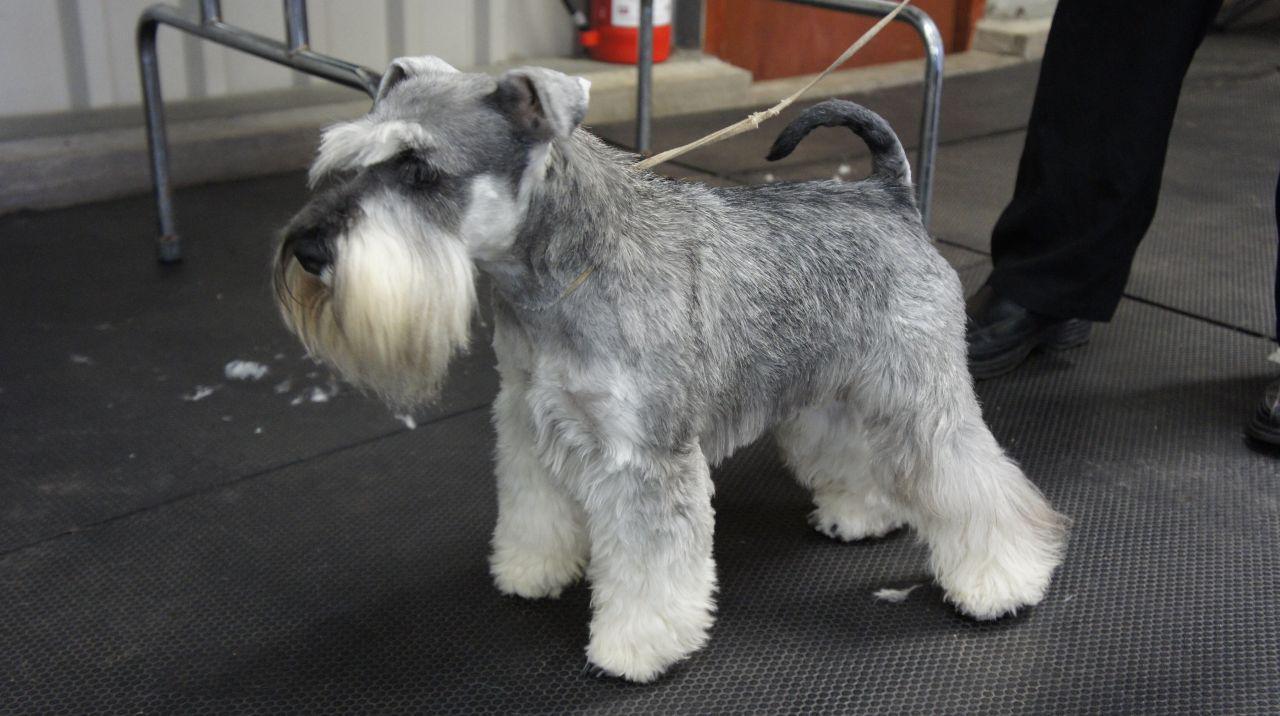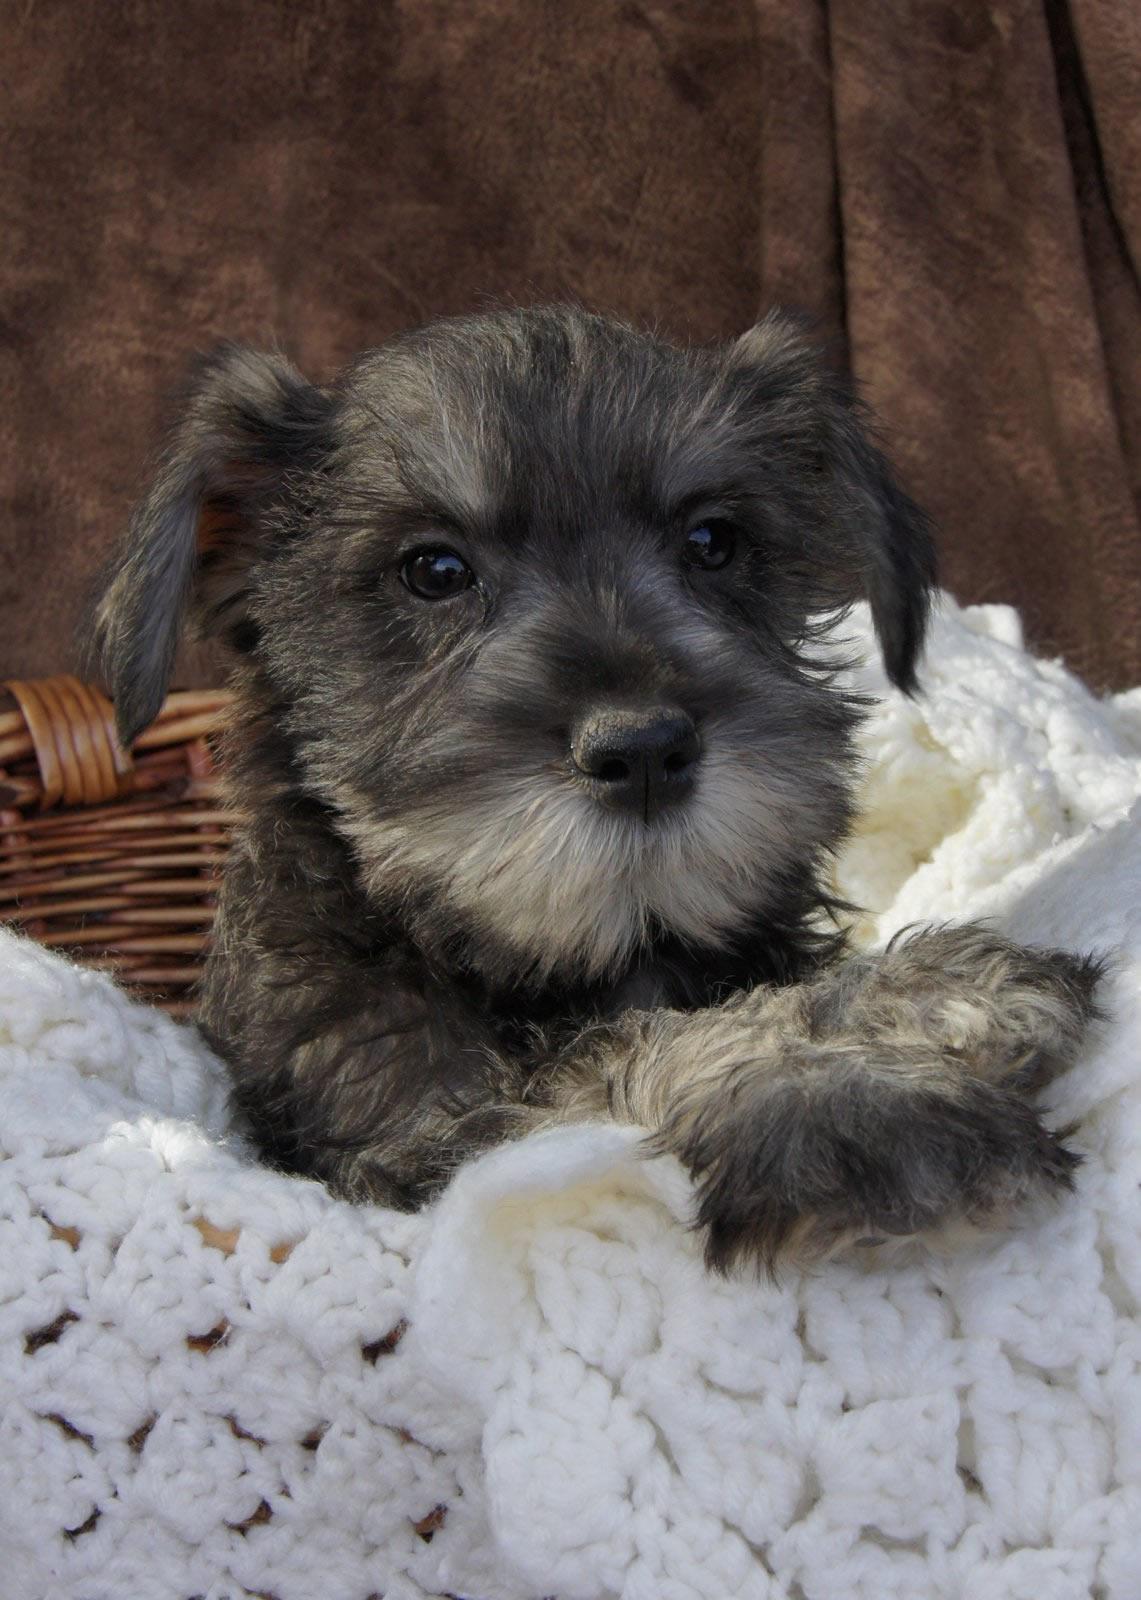The first image is the image on the left, the second image is the image on the right. Examine the images to the left and right. Is the description "The left image contains at least three dogs." accurate? Answer yes or no. No. The first image is the image on the left, the second image is the image on the right. Given the left and right images, does the statement "The combined images contain five schnauzers, and at least four are sitting upright." hold true? Answer yes or no. No. 